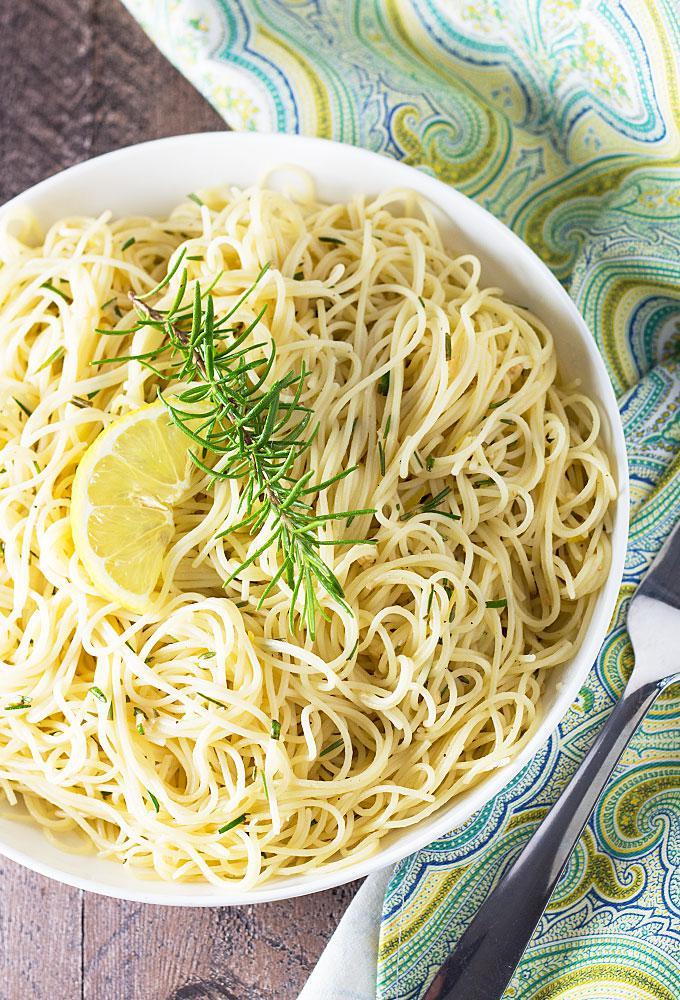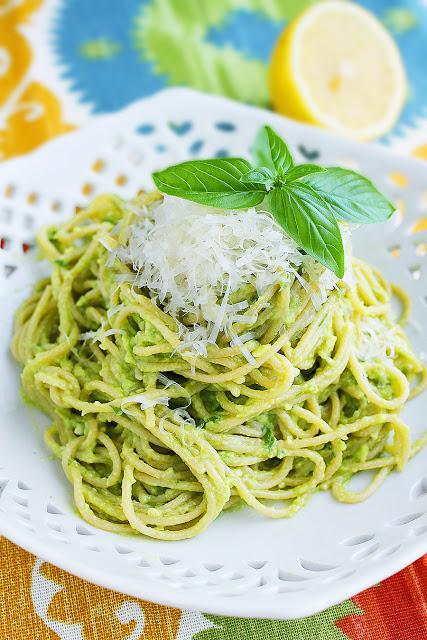The first image is the image on the left, the second image is the image on the right. Examine the images to the left and right. Is the description "A single wedge of lemon sits on top of a meatless noodle dish in the image on the left." accurate? Answer yes or no. Yes. The first image is the image on the left, the second image is the image on the right. Given the left and right images, does the statement "An image shows a slice of citrus fruit garnishing a white bowl of noodles on a checkered cloth." hold true? Answer yes or no. No. 